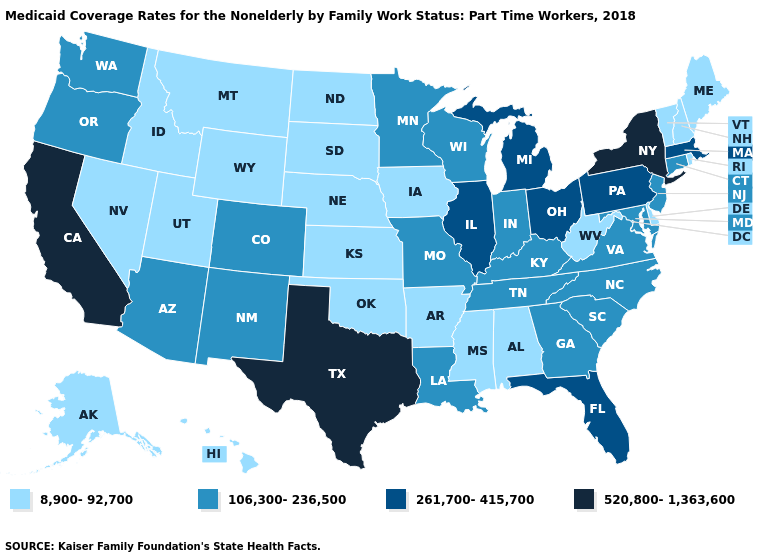Name the states that have a value in the range 261,700-415,700?
Give a very brief answer. Florida, Illinois, Massachusetts, Michigan, Ohio, Pennsylvania. What is the highest value in the West ?
Be succinct. 520,800-1,363,600. Does the first symbol in the legend represent the smallest category?
Answer briefly. Yes. Does Alabama have the lowest value in the USA?
Short answer required. Yes. Name the states that have a value in the range 520,800-1,363,600?
Short answer required. California, New York, Texas. Does Massachusetts have a lower value than New Jersey?
Write a very short answer. No. What is the highest value in states that border Arizona?
Short answer required. 520,800-1,363,600. What is the value of Oklahoma?
Be succinct. 8,900-92,700. Does Florida have the lowest value in the USA?
Quick response, please. No. What is the value of Kentucky?
Short answer required. 106,300-236,500. How many symbols are there in the legend?
Short answer required. 4. Is the legend a continuous bar?
Give a very brief answer. No. Does Arkansas have the lowest value in the South?
Answer briefly. Yes. What is the lowest value in the MidWest?
Quick response, please. 8,900-92,700. 